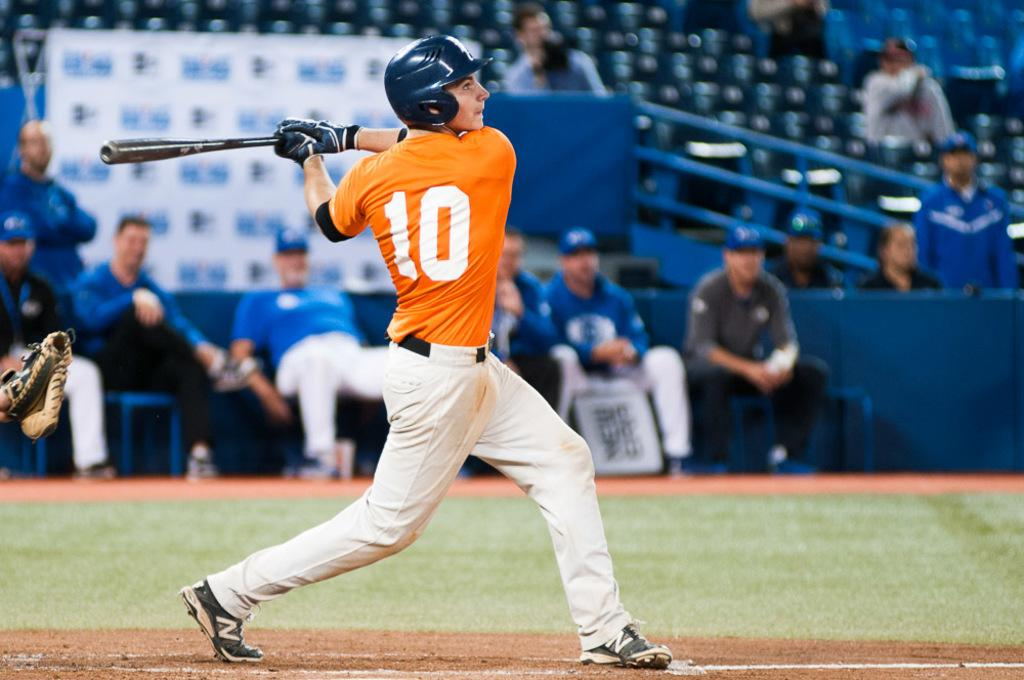<image>
Provide a brief description of the given image. A guy in a baseball uniform has the number 10 on the back of his jersey. 